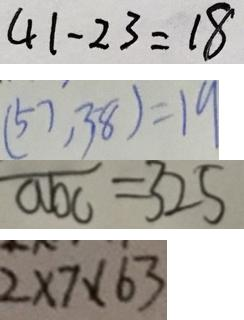<formula> <loc_0><loc_0><loc_500><loc_500>4 1 - 2 3 = 1 8 
 ( 5 7 , 3 8 ) = 1 9 
 \overline { a b c } = 3 2 5 
 2 \times 7 \times 6 3</formula> 